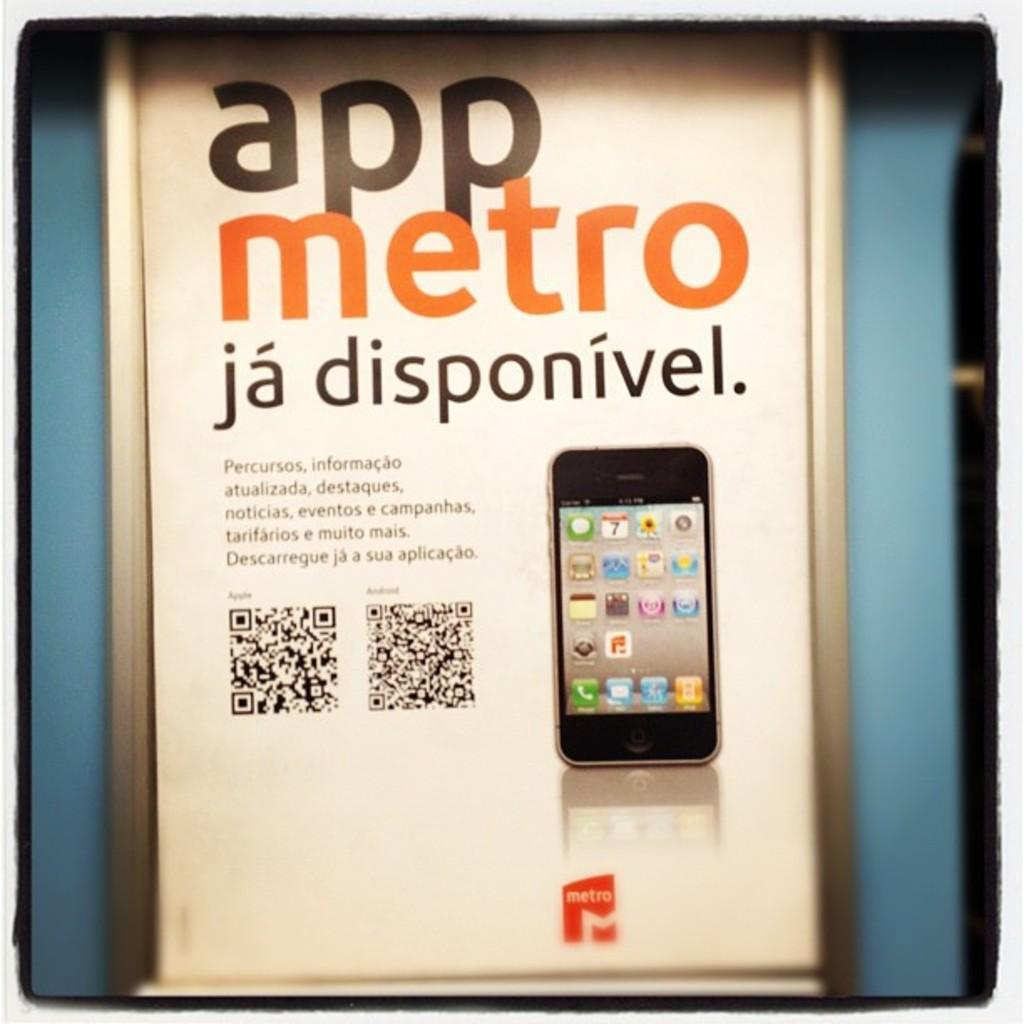<image>
Share a concise interpretation of the image provided. A white poster with a phone on it advertising the Metro app. 